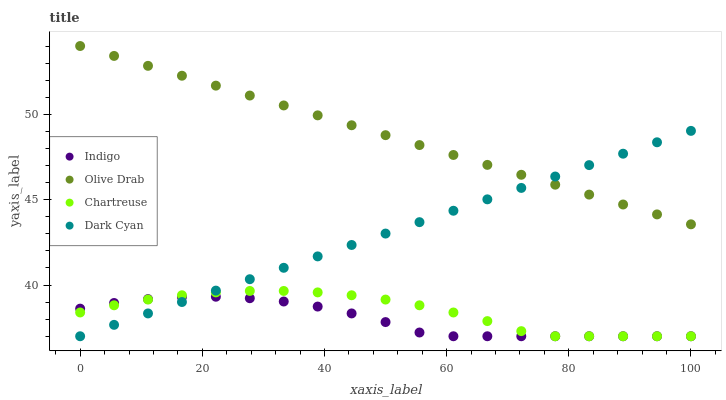Does Indigo have the minimum area under the curve?
Answer yes or no. Yes. Does Olive Drab have the maximum area under the curve?
Answer yes or no. Yes. Does Chartreuse have the minimum area under the curve?
Answer yes or no. No. Does Chartreuse have the maximum area under the curve?
Answer yes or no. No. Is Dark Cyan the smoothest?
Answer yes or no. Yes. Is Chartreuse the roughest?
Answer yes or no. Yes. Is Indigo the smoothest?
Answer yes or no. No. Is Indigo the roughest?
Answer yes or no. No. Does Dark Cyan have the lowest value?
Answer yes or no. Yes. Does Olive Drab have the lowest value?
Answer yes or no. No. Does Olive Drab have the highest value?
Answer yes or no. Yes. Does Chartreuse have the highest value?
Answer yes or no. No. Is Indigo less than Olive Drab?
Answer yes or no. Yes. Is Olive Drab greater than Chartreuse?
Answer yes or no. Yes. Does Indigo intersect Dark Cyan?
Answer yes or no. Yes. Is Indigo less than Dark Cyan?
Answer yes or no. No. Is Indigo greater than Dark Cyan?
Answer yes or no. No. Does Indigo intersect Olive Drab?
Answer yes or no. No. 